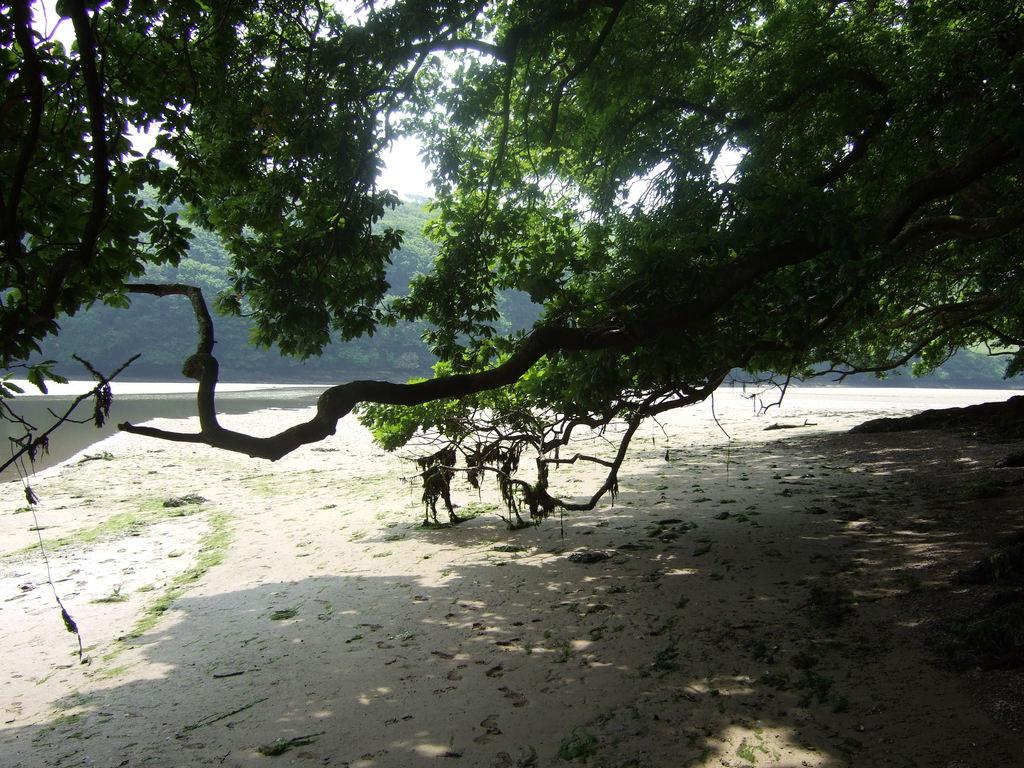What type of vegetation can be seen in the image? There are trees in the image. What body of water is present in the image? There is a lake in the image. What part of the natural environment is visible in the image? The sky is visible in the image. What type of heart can be seen beating in the image? There is no heart visible in the image; it features trees, a lake, and the sky. 